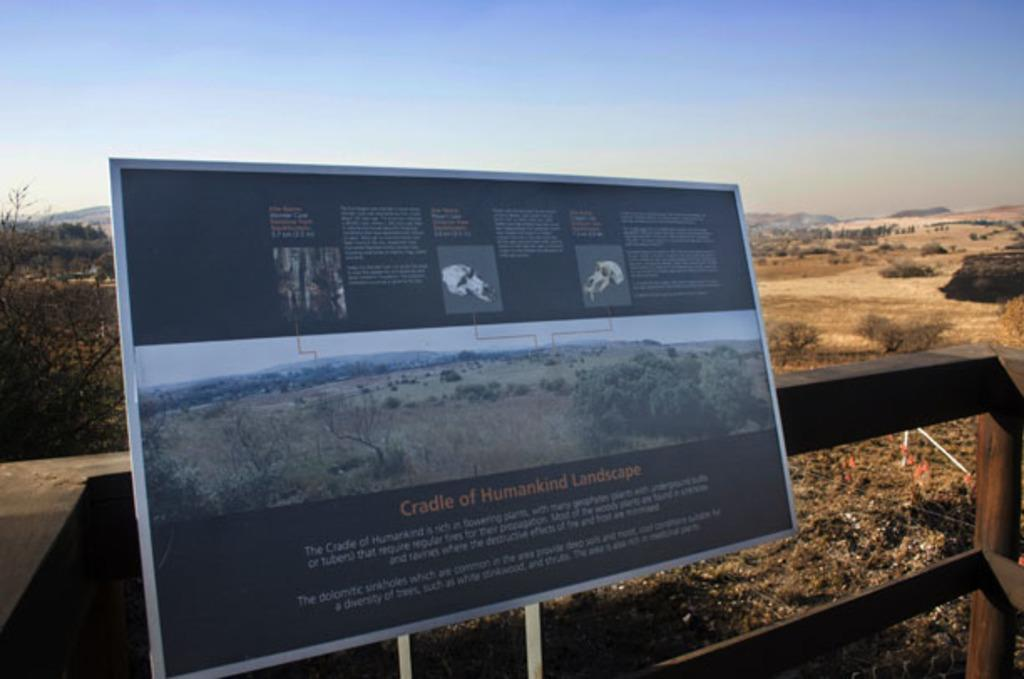What is mentioned on the sign board in the image? The sign board mentions the "cradle of humankind landscape" in the image. What can be seen in the background of the image? There is a wooden fence, a group of trees, mountains, and the sky visible in the background of the image. What type of butter is being spread on the wooden fence in the image? There is no butter present in the image; it features a sign board and various landscape elements in the background. 